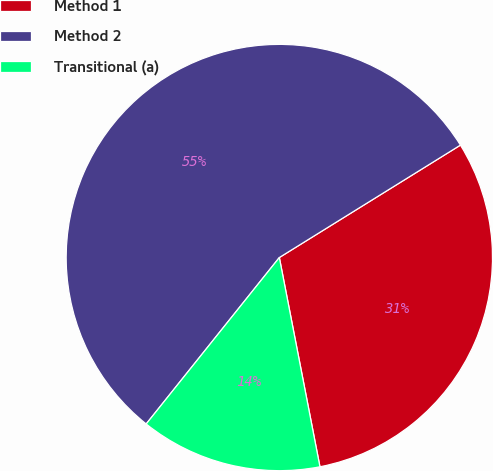Convert chart. <chart><loc_0><loc_0><loc_500><loc_500><pie_chart><fcel>Method 1<fcel>Method 2<fcel>Transitional (a)<nl><fcel>30.79%<fcel>55.42%<fcel>13.79%<nl></chart> 